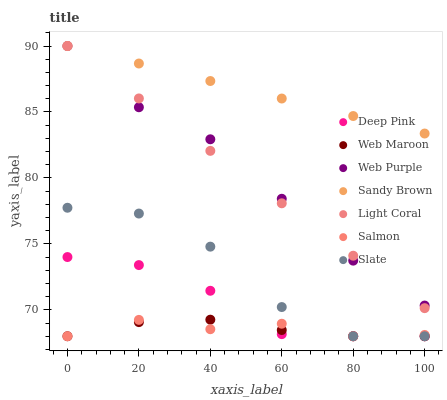Does Salmon have the minimum area under the curve?
Answer yes or no. Yes. Does Sandy Brown have the maximum area under the curve?
Answer yes or no. Yes. Does Slate have the minimum area under the curve?
Answer yes or no. No. Does Slate have the maximum area under the curve?
Answer yes or no. No. Is Light Coral the smoothest?
Answer yes or no. Yes. Is Slate the roughest?
Answer yes or no. Yes. Is Salmon the smoothest?
Answer yes or no. No. Is Salmon the roughest?
Answer yes or no. No. Does Deep Pink have the lowest value?
Answer yes or no. Yes. Does Light Coral have the lowest value?
Answer yes or no. No. Does Sandy Brown have the highest value?
Answer yes or no. Yes. Does Slate have the highest value?
Answer yes or no. No. Is Deep Pink less than Web Purple?
Answer yes or no. Yes. Is Web Purple greater than Web Maroon?
Answer yes or no. Yes. Does Web Purple intersect Light Coral?
Answer yes or no. Yes. Is Web Purple less than Light Coral?
Answer yes or no. No. Is Web Purple greater than Light Coral?
Answer yes or no. No. Does Deep Pink intersect Web Purple?
Answer yes or no. No. 